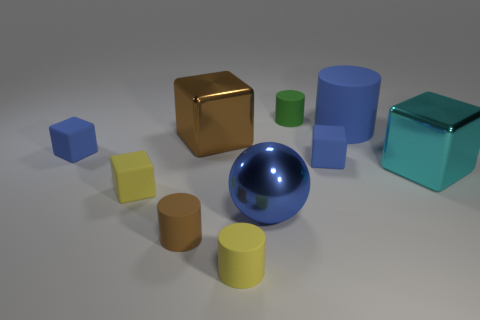What number of small blocks are the same material as the ball?
Ensure brevity in your answer.  0. How many other things are the same size as the cyan metallic thing?
Provide a succinct answer. 3. Are there any balls that have the same size as the cyan shiny cube?
Give a very brief answer. Yes. There is a small cylinder in front of the tiny brown matte object; is it the same color as the big matte cylinder?
Offer a very short reply. No. How many things are cyan metal objects or big rubber cylinders?
Provide a short and direct response. 2. Does the metal object in front of the cyan metal thing have the same size as the big blue matte thing?
Provide a succinct answer. Yes. There is a block that is right of the tiny yellow cube and on the left side of the large blue metallic ball; how big is it?
Your answer should be very brief. Large. How many other things are the same shape as the green thing?
Make the answer very short. 3. How many other objects are there of the same material as the brown cube?
Make the answer very short. 2. What size is the blue matte thing that is the same shape as the small green thing?
Give a very brief answer. Large. 